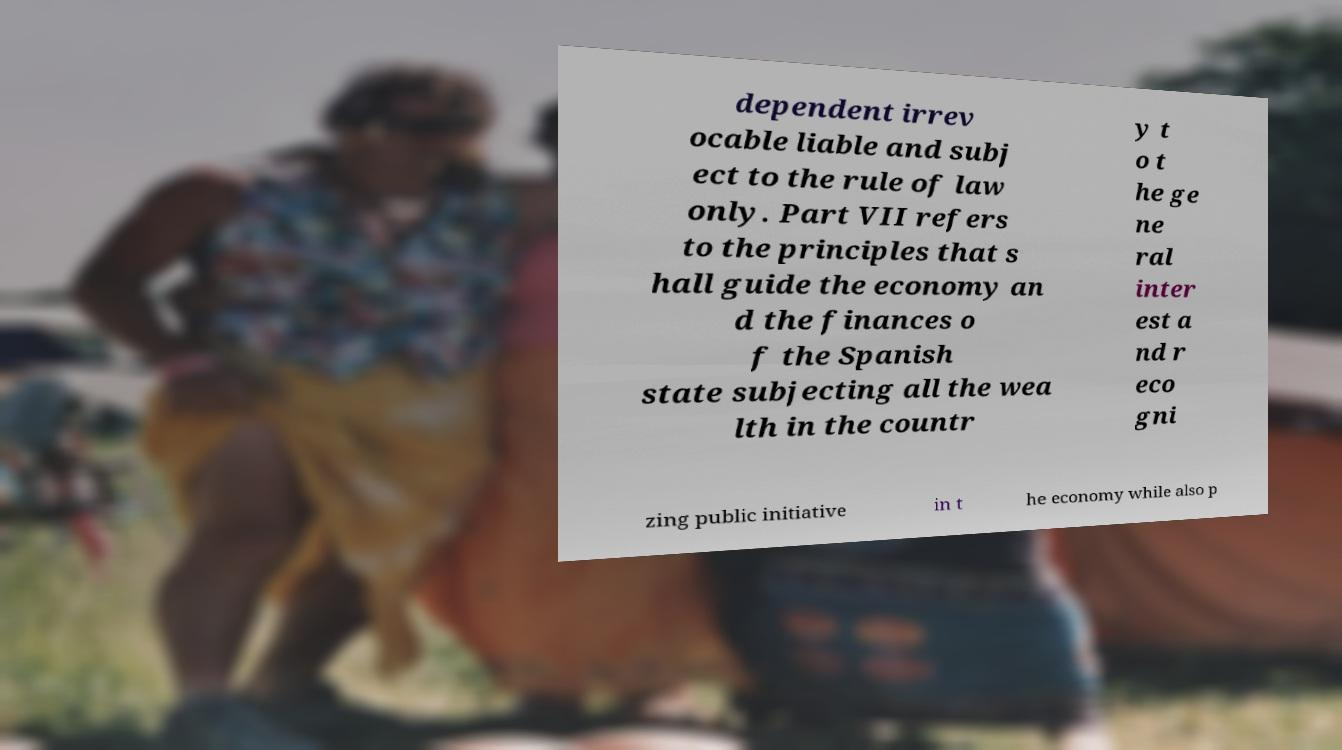I need the written content from this picture converted into text. Can you do that? dependent irrev ocable liable and subj ect to the rule of law only. Part VII refers to the principles that s hall guide the economy an d the finances o f the Spanish state subjecting all the wea lth in the countr y t o t he ge ne ral inter est a nd r eco gni zing public initiative in t he economy while also p 